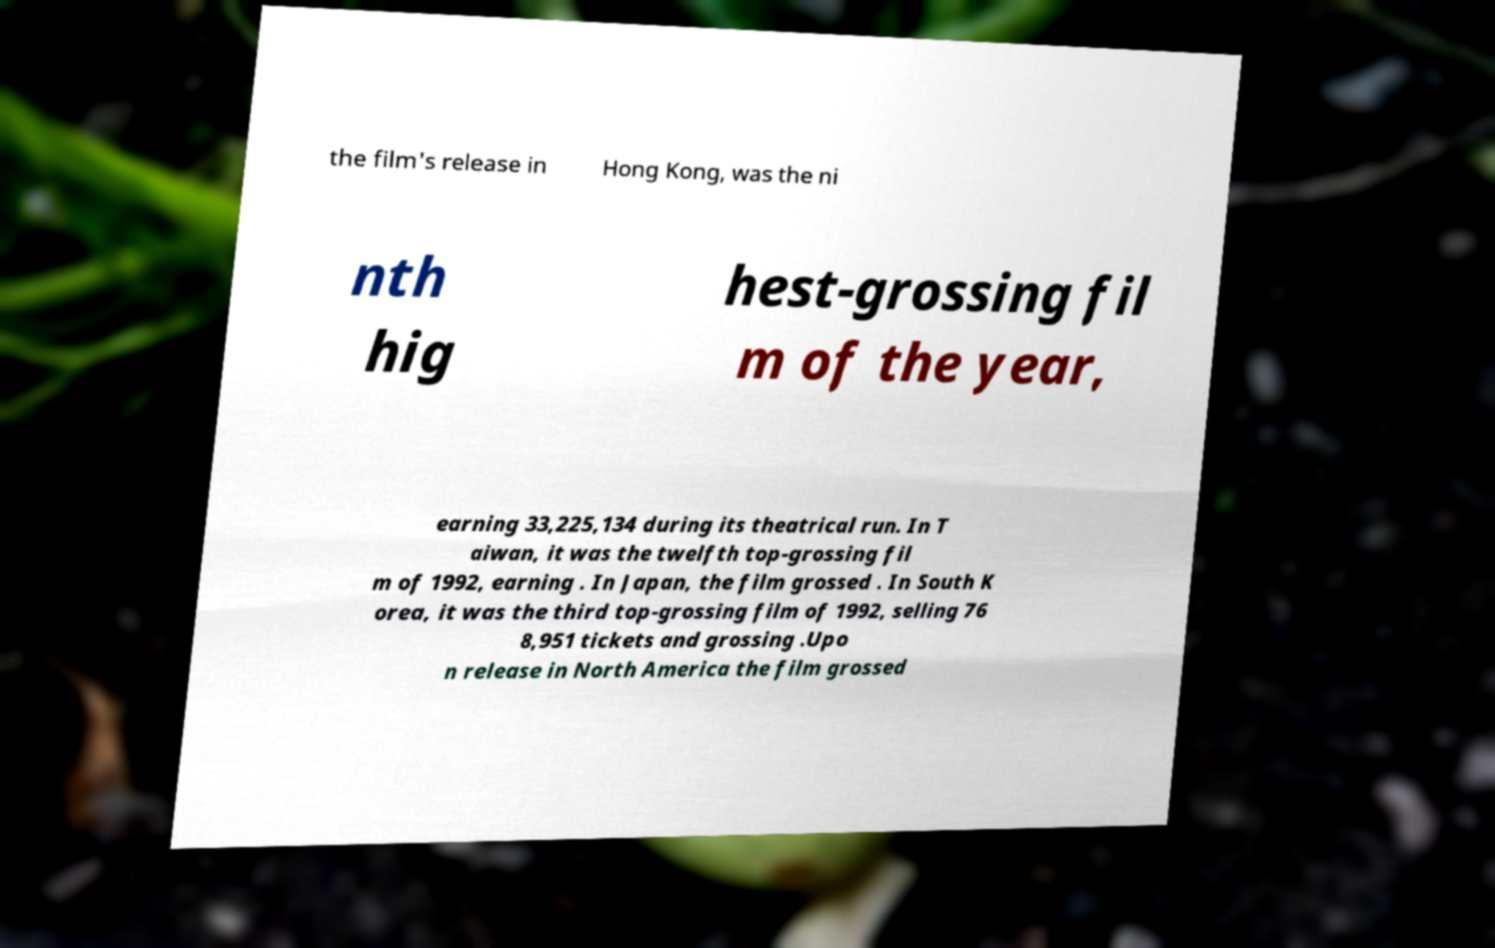Could you assist in decoding the text presented in this image and type it out clearly? the film's release in Hong Kong, was the ni nth hig hest-grossing fil m of the year, earning 33,225,134 during its theatrical run. In T aiwan, it was the twelfth top-grossing fil m of 1992, earning . In Japan, the film grossed . In South K orea, it was the third top-grossing film of 1992, selling 76 8,951 tickets and grossing .Upo n release in North America the film grossed 